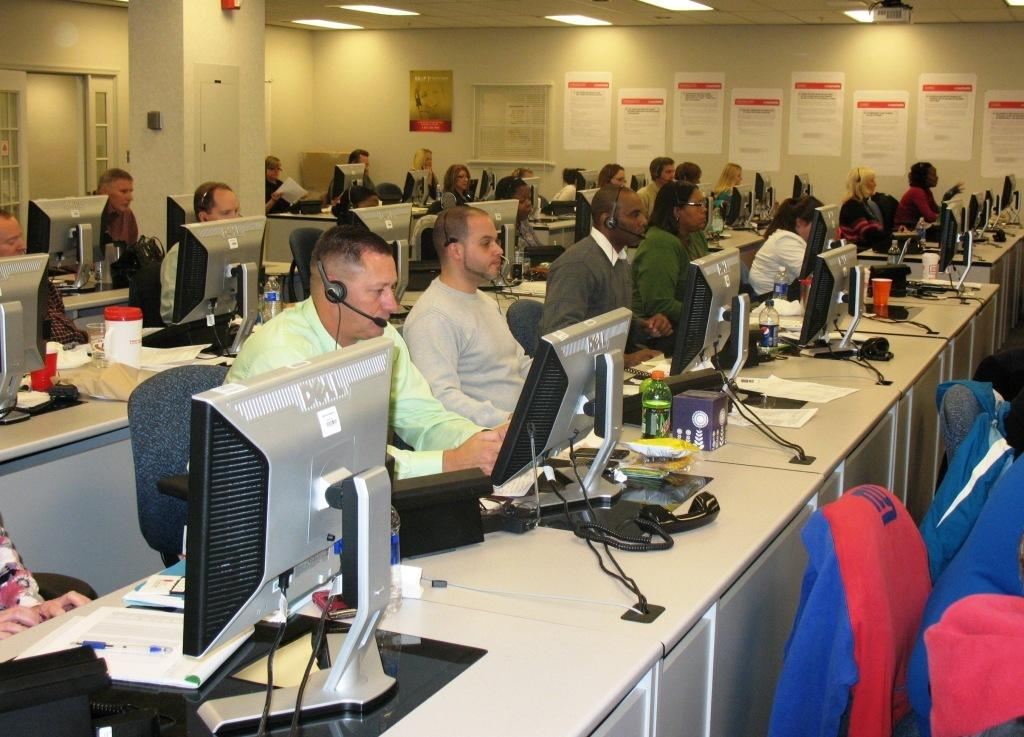Provide a one-sentence caption for the provided image. A large group of people sit with Dell computer monitors in front of them. 